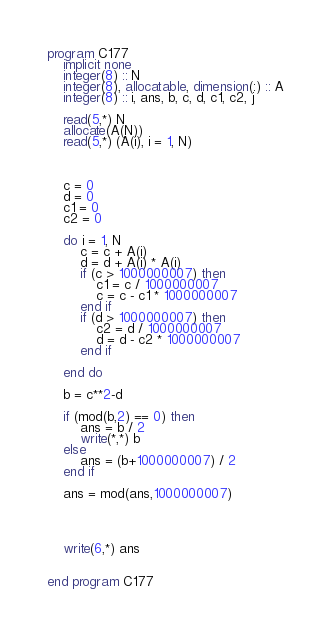<code> <loc_0><loc_0><loc_500><loc_500><_FORTRAN_>program C177
    implicit none
    integer(8) :: N
    integer(8), allocatable, dimension(:) :: A
    integer(8) :: i, ans, b, c, d, c1, c2, j

    read(5,*) N
    allocate(A(N))
    read(5,*) (A(i), i = 1, N)

    

    c = 0
    d = 0
    c1 = 0
    c2 = 0

    do i = 1, N
        c = c + A(i)
        d = d + A(i) * A(i)
        if (c > 1000000007) then
            c1 = c / 1000000007
            c = c - c1 * 1000000007
        end if        
        if (d > 1000000007) then
            c2 = d / 1000000007
            d = d - c2 * 1000000007
        end if
 
    end do

    b = c**2-d

    if (mod(b,2) == 0) then
        ans = b / 2
        write(*,*) b
    else
        ans = (b+1000000007) / 2
    end if

    ans = mod(ans,1000000007)

    


    write(6,*) ans

    
end program C177</code> 